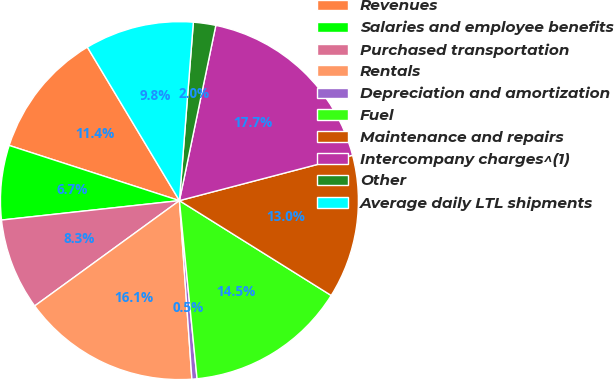Convert chart. <chart><loc_0><loc_0><loc_500><loc_500><pie_chart><fcel>Revenues<fcel>Salaries and employee benefits<fcel>Purchased transportation<fcel>Rentals<fcel>Depreciation and amortization<fcel>Fuel<fcel>Maintenance and repairs<fcel>Intercompany charges^(1)<fcel>Other<fcel>Average daily LTL shipments<nl><fcel>11.41%<fcel>6.72%<fcel>8.28%<fcel>16.1%<fcel>0.46%<fcel>14.54%<fcel>12.97%<fcel>17.66%<fcel>2.02%<fcel>9.84%<nl></chart> 